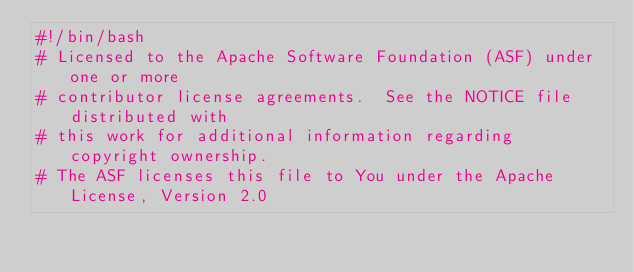Convert code to text. <code><loc_0><loc_0><loc_500><loc_500><_Bash_>#!/bin/bash
# Licensed to the Apache Software Foundation (ASF) under one or more
# contributor license agreements.  See the NOTICE file distributed with
# this work for additional information regarding copyright ownership.
# The ASF licenses this file to You under the Apache License, Version 2.0</code> 